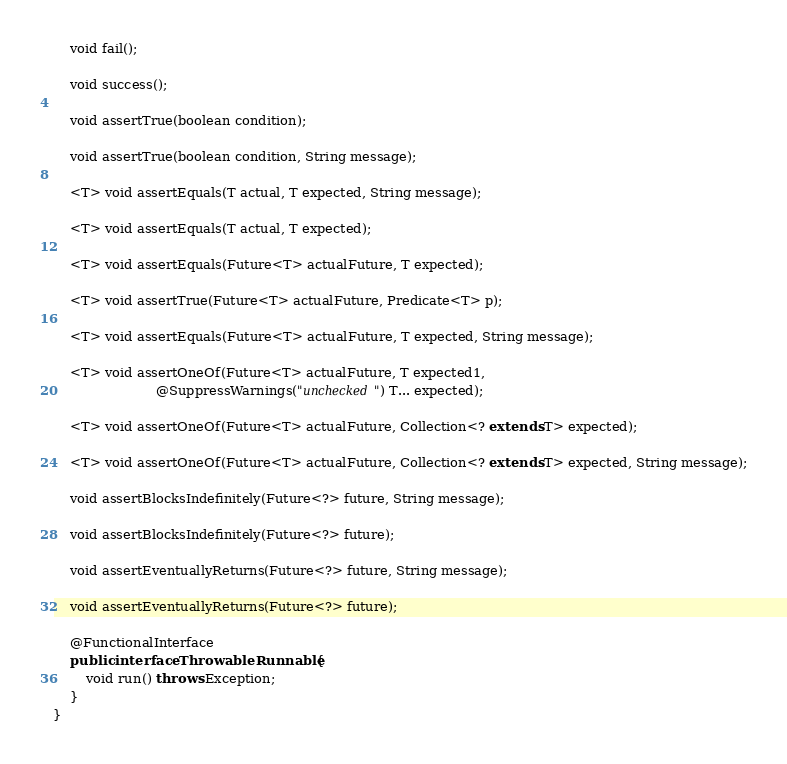<code> <loc_0><loc_0><loc_500><loc_500><_Java_>
    void fail();

    void success();

    void assertTrue(boolean condition);

    void assertTrue(boolean condition, String message);

    <T> void assertEquals(T actual, T expected, String message);

    <T> void assertEquals(T actual, T expected);

    <T> void assertEquals(Future<T> actualFuture, T expected);

    <T> void assertTrue(Future<T> actualFuture, Predicate<T> p);

    <T> void assertEquals(Future<T> actualFuture, T expected, String message);

    <T> void assertOneOf(Future<T> actualFuture, T expected1,
                         @SuppressWarnings("unchecked") T... expected);

    <T> void assertOneOf(Future<T> actualFuture, Collection<? extends T> expected);

    <T> void assertOneOf(Future<T> actualFuture, Collection<? extends T> expected, String message);

    void assertBlocksIndefinitely(Future<?> future, String message);

    void assertBlocksIndefinitely(Future<?> future);

    void assertEventuallyReturns(Future<?> future, String message);

    void assertEventuallyReturns(Future<?> future);

    @FunctionalInterface
    public interface ThrowableRunnable {
        void run() throws Exception;
    }
}
</code> 